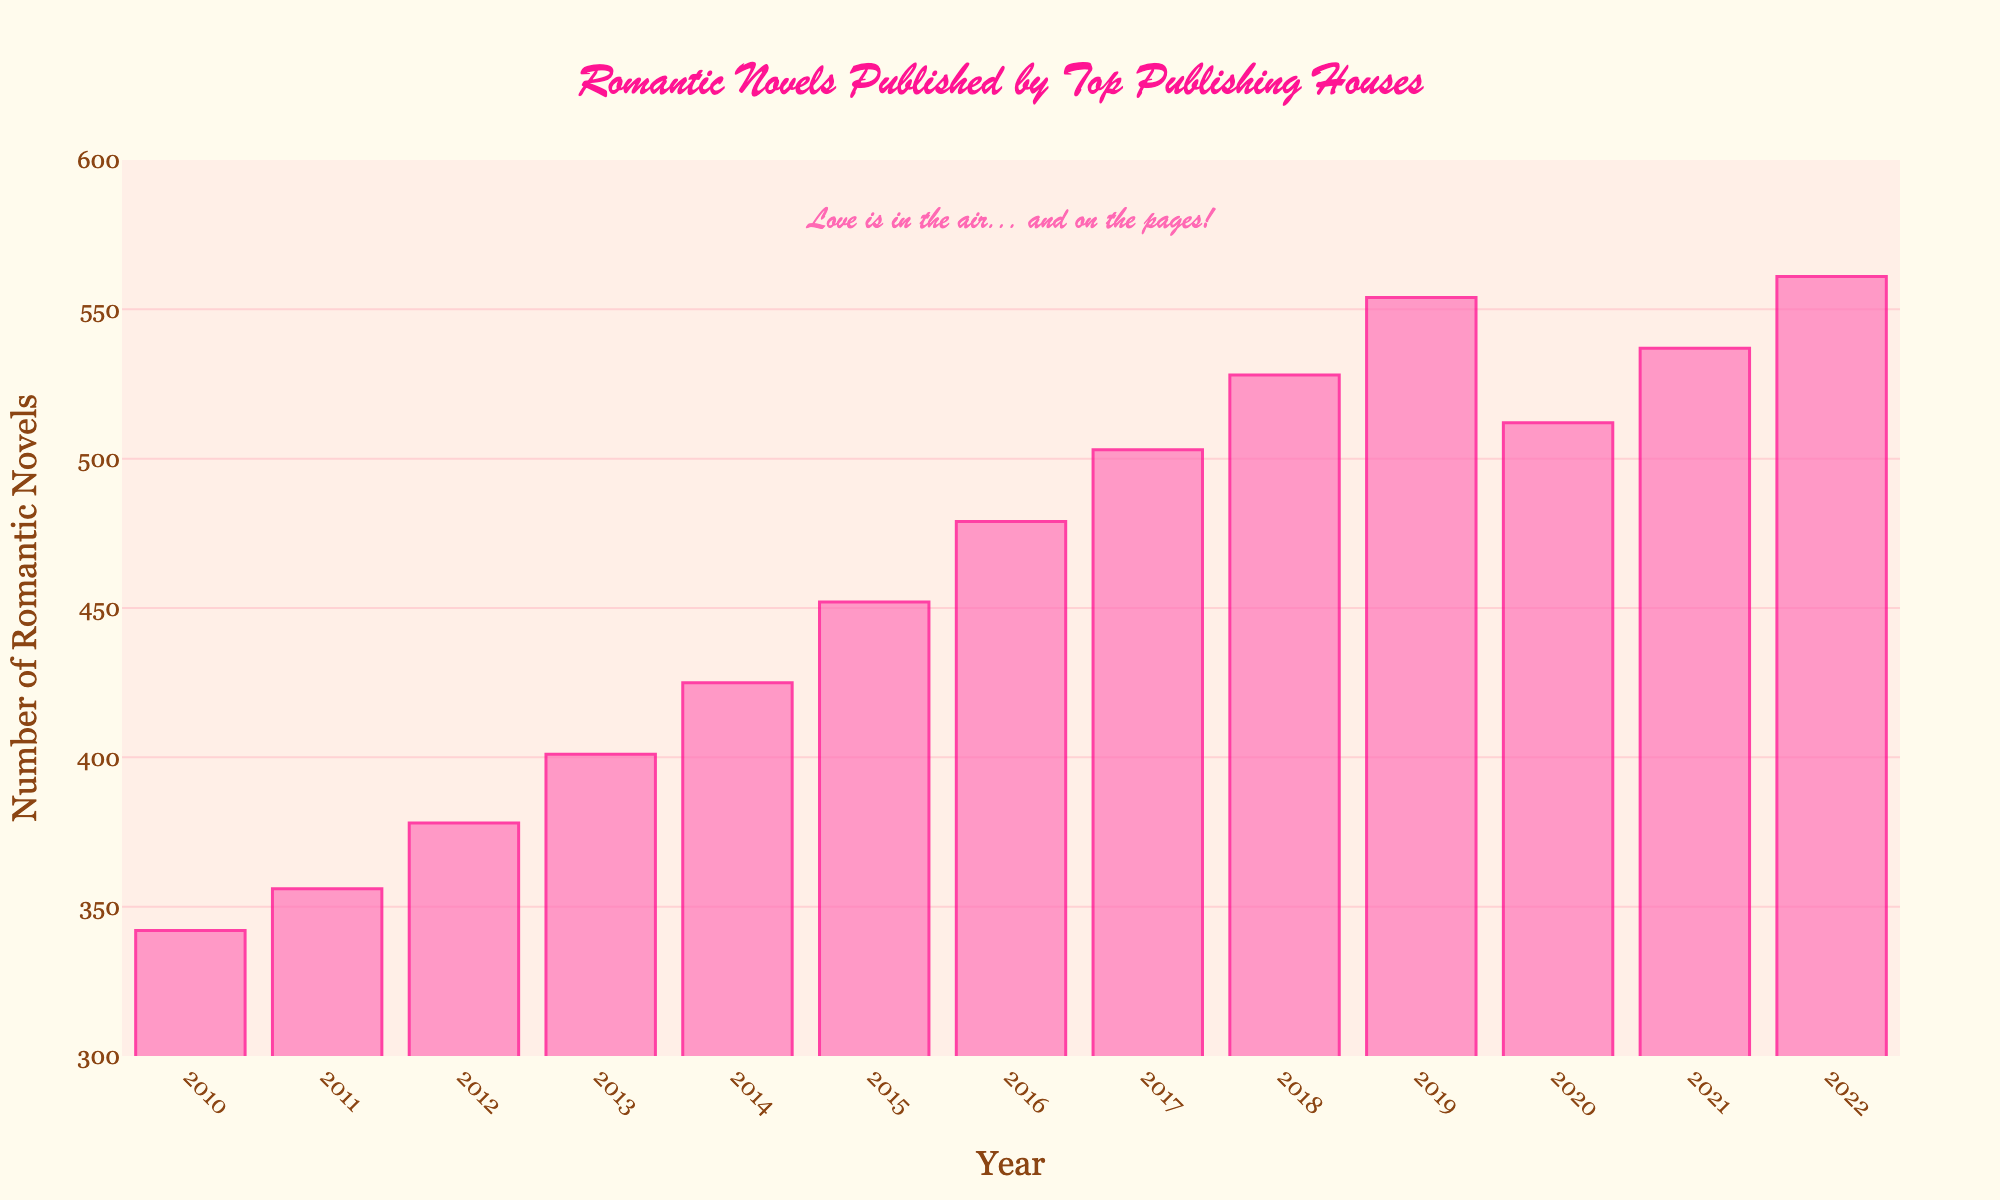What's the trend in the number of romantic novels published from 2010 to 2022? By looking at the bars from 2010 to 2022, you can see an upward trend with occasional dips. The height of the bars generally increases over the years, indicating more novels were published annually.
Answer: upward trend Which year saw the highest number of romantic novels published? Identify the tallest bar in the chart. The year corresponding to the highest bar is 2022, with 561 novels published.
Answer: 2022 Compare the number of romantic novels published in 2010 and 2022. How much did it increase? The number of novels in 2010 is 342 and in 2022 it's 561. Subtract the 2010 value from 2022 to find the increase: 561 - 342 = 219. So, it increased by 219.
Answer: 219 Which year had the lowest number of romantic novels published and how many were published that year? Locate the shortest bar on the chart, which corresponds to the year 2010, with 342 novels published.
Answer: 2010, 342 How does the number of romantic novels published in 2015 compare to 2018? Check the bar heights for 2015 and 2018. In 2015, 452 novels were published, and in 2018, 528 novels were published. Thus, 2018 had more novels published.
Answer: 2018 had more Did the number of romantic novels published in 2020 increase or decrease compared to 2019? By how much? Compare the bar heights of 2019 and 2020. In 2019, 554 novels were published, and in 2020, that number was 512. So, there was a decrease of 42 novels: 554 - 512 = 42.
Answer: decrease, 42 What is the average number of romantic novels published per year from 2010 to 2015? Sum the number of novels from 2010 to 2015: 342 + 356 + 378 + 401 + 425 + 452 = 2354. Now, divide by the number of years (6): 2354 / 6 ≈ 392.33.
Answer: 392.33 Identify the year where the number of romantic novels published first crossed the 500 mark. Locate the first bar where the value exceeds 500. This occurs in the year 2017 with 503 novels published.
Answer: 2017 What are the approximate ranges for the y-axis? From the visual scale of the y-axis, the range spans from 300 to 600, as indicated by the axis markings and the grid lines.
Answer: 300 to 600 Between which consecutive years did the number of romantic novels published see the largest increase? Calculate the differences between consecutive years and identify the largest one. The biggest difference is between 2018 and 2019: 554 - 528 = 26.
Answer: 2018 and 2019 